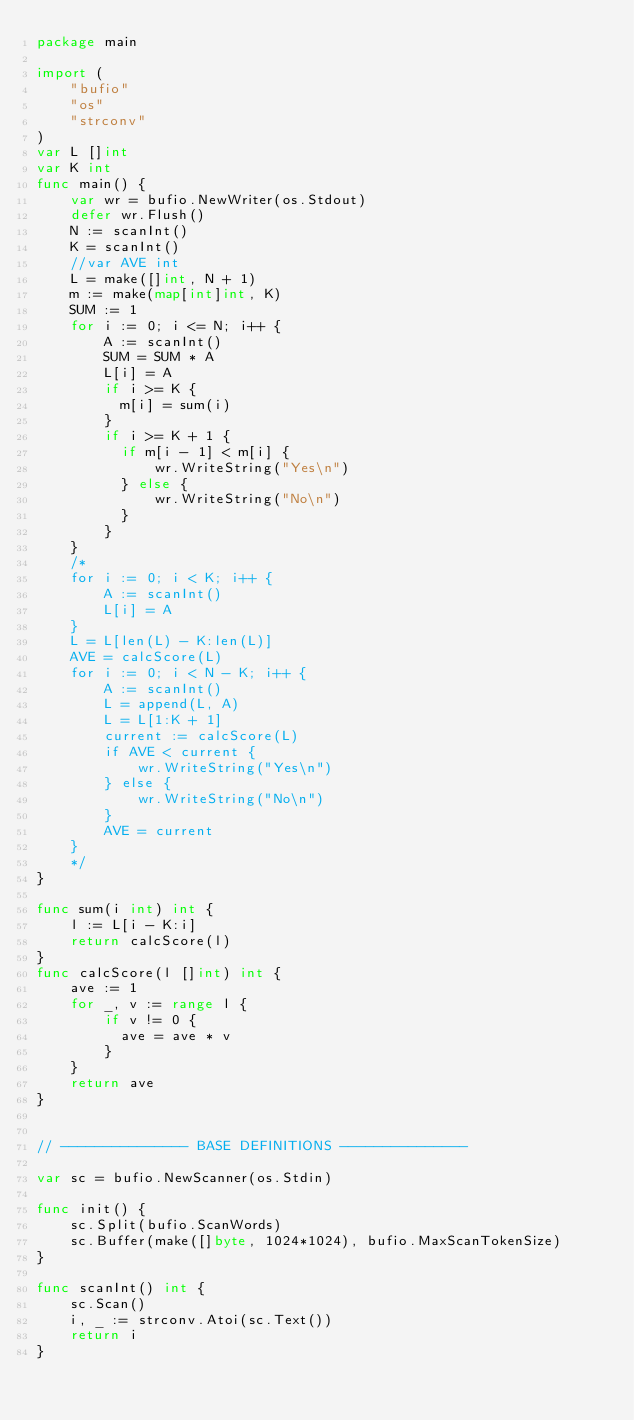Convert code to text. <code><loc_0><loc_0><loc_500><loc_500><_Go_>package main
 
import (
	"bufio"
	"os"
	"strconv"
)
var L []int
var K int
func main() {
    var wr = bufio.NewWriter(os.Stdout)
    defer wr.Flush()
	N := scanInt()
	K = scanInt()
	//var AVE int
	L = make([]int, N + 1)
	m := make(map[int]int, K)
	SUM := 1
	for i := 0; i <= N; i++ {
		A := scanInt()
		SUM = SUM * A
		L[i] = A
		if i >= K {
		  m[i] = sum(i)
		}
		if i >= K + 1 {
          if m[i - 1] < m[i] {
              wr.WriteString("Yes\n")
		  } else {
              wr.WriteString("No\n")
		  }
		}
	}
	/*
	for i := 0; i < K; i++ {
		A := scanInt()
		L[i] = A
	}
	L = L[len(L) - K:len(L)]
	AVE = calcScore(L)
	for i := 0; i < N - K; i++ {
		A := scanInt()
		L = append(L, A)
		L = L[1:K + 1]
		current := calcScore(L)
		if AVE < current {
            wr.WriteString("Yes\n")
		} else {
            wr.WriteString("No\n")
		}
		AVE = current
	}
	*/
}

func sum(i int) int {
	l := L[i - K:i]
	return calcScore(l)
}
func calcScore(l []int) int {
	ave := 1
	for _, v := range l {
		if v != 0 {
		  ave = ave * v
		}
	}
	return ave
}


// --------------- BASE DEFINITIONS ---------------

var sc = bufio.NewScanner(os.Stdin)
 
func init() {
	sc.Split(bufio.ScanWords)
	sc.Buffer(make([]byte, 1024*1024), bufio.MaxScanTokenSize)
}

func scanInt() int {
	sc.Scan()
	i, _ := strconv.Atoi(sc.Text())
	return i
}
</code> 